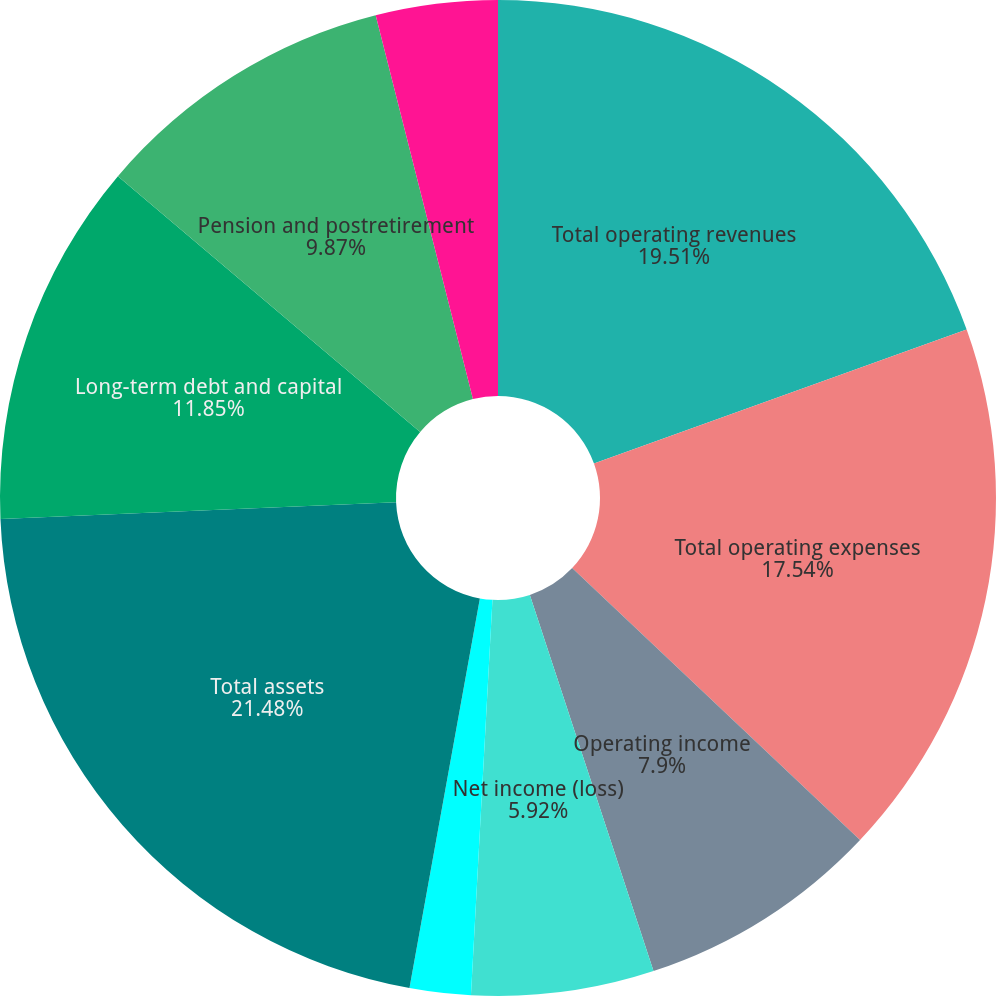Convert chart. <chart><loc_0><loc_0><loc_500><loc_500><pie_chart><fcel>Total operating revenues<fcel>Total operating expenses<fcel>Operating income<fcel>Net income (loss)<fcel>Basic<fcel>Diluted<fcel>Total assets<fcel>Long-term debt and capital<fcel>Pension and postretirement<fcel>Stockholders' equity (deficit)<nl><fcel>19.51%<fcel>17.54%<fcel>7.9%<fcel>5.92%<fcel>1.98%<fcel>0.0%<fcel>21.49%<fcel>11.85%<fcel>9.87%<fcel>3.95%<nl></chart> 